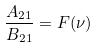Convert formula to latex. <formula><loc_0><loc_0><loc_500><loc_500>\frac { A _ { 2 1 } } { B _ { 2 1 } } = F ( \nu )</formula> 